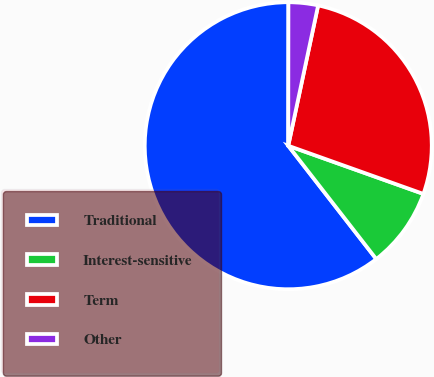Convert chart. <chart><loc_0><loc_0><loc_500><loc_500><pie_chart><fcel>Traditional<fcel>Interest-sensitive<fcel>Term<fcel>Other<nl><fcel>60.53%<fcel>9.04%<fcel>27.11%<fcel>3.32%<nl></chart> 